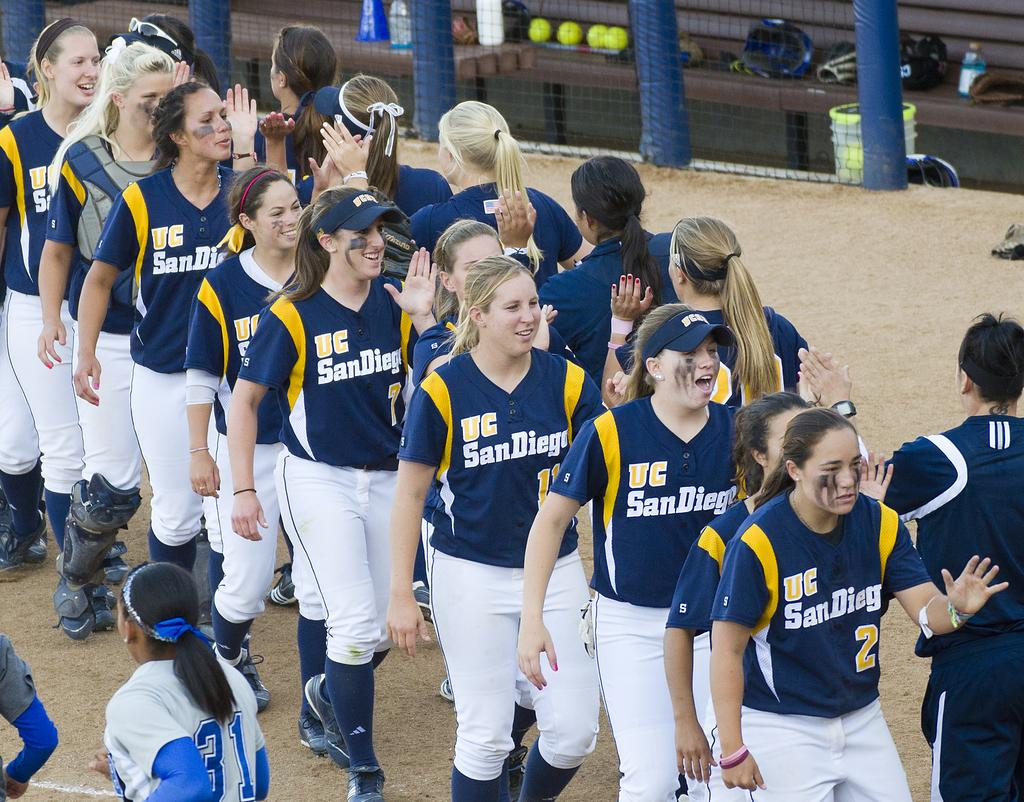<image>
Create a compact narrative representing the image presented. The team shown here is from the city of San Diego 